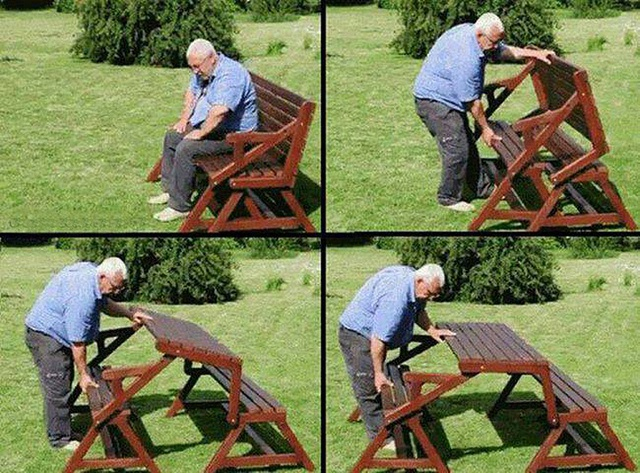Describe the objects in this image and their specific colors. I can see bench in black, maroon, olive, and gray tones, bench in black, maroon, brown, and tan tones, bench in black, maroon, and brown tones, people in black, gray, darkgray, and lavender tones, and people in black, gray, darkgray, and lavender tones in this image. 